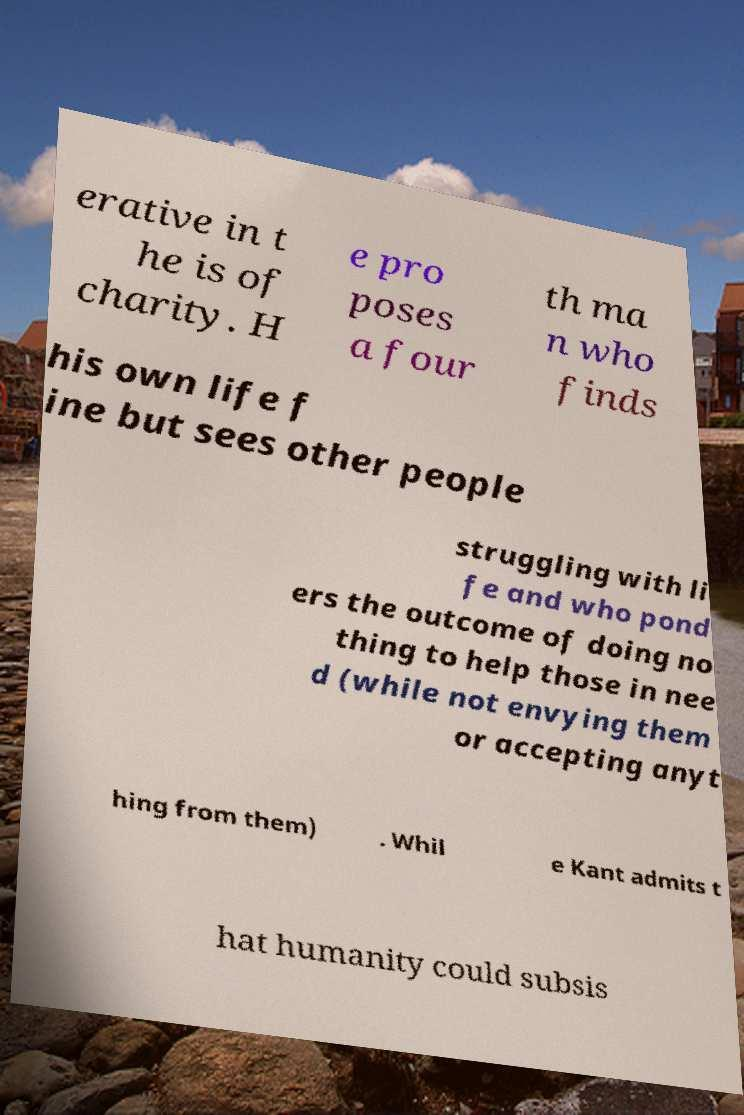What messages or text are displayed in this image? I need them in a readable, typed format. erative in t he is of charity. H e pro poses a four th ma n who finds his own life f ine but sees other people struggling with li fe and who pond ers the outcome of doing no thing to help those in nee d (while not envying them or accepting anyt hing from them) . Whil e Kant admits t hat humanity could subsis 